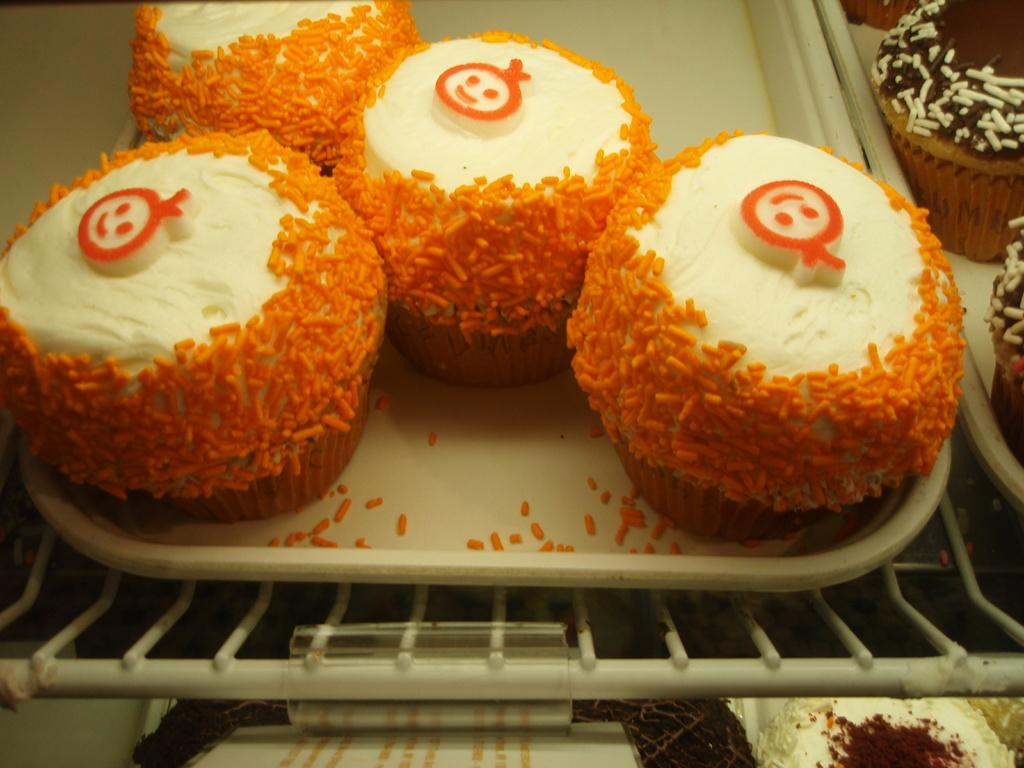What type of food is visible in the image? There are cupcakes in the image. How are the cupcakes arranged or stored? The cupcakes are kept in a tray. What colors can be seen on the cupcakes? Some cupcakes are orange and white in color, while others are brown. What type of stove is used to bake the cupcakes in the image? There is no stove present in the image, as it only shows the cupcakes in a tray. 